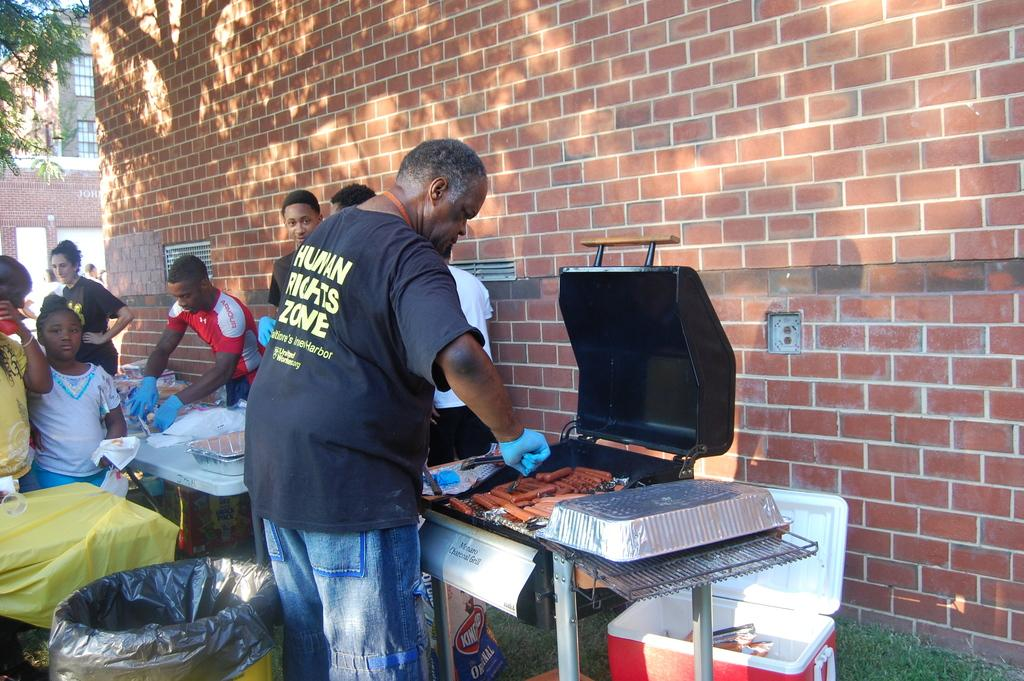<image>
Present a compact description of the photo's key features. A man grilling hot dogs with a shirt saying human rights zone 